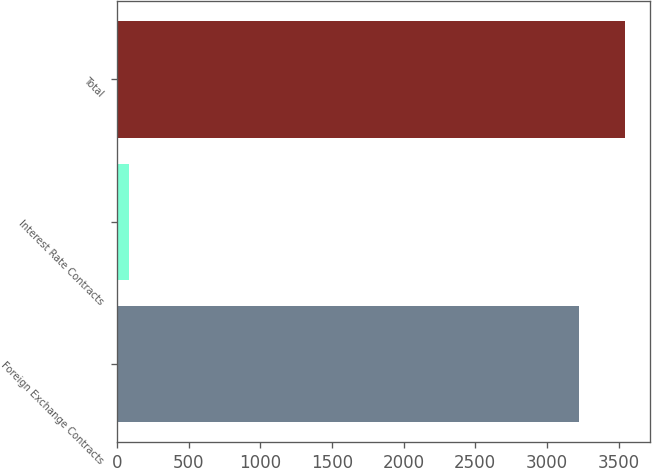Convert chart. <chart><loc_0><loc_0><loc_500><loc_500><bar_chart><fcel>Foreign Exchange Contracts<fcel>Interest Rate Contracts<fcel>Total<nl><fcel>3221.7<fcel>85.2<fcel>3543.87<nl></chart> 